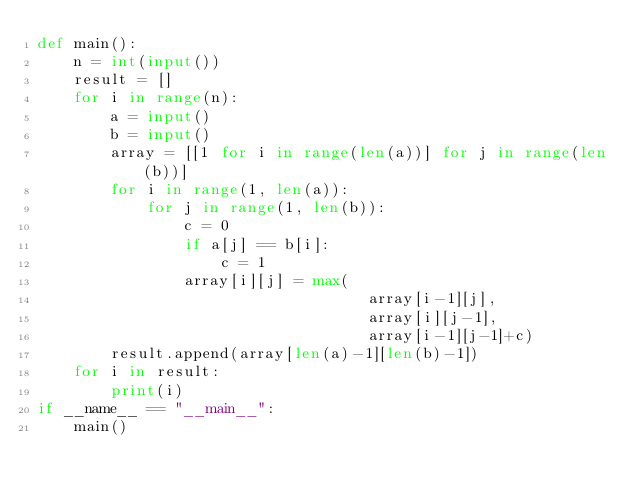<code> <loc_0><loc_0><loc_500><loc_500><_Python_>def main():
    n = int(input())
    result = []
    for i in range(n):
        a = input()
        b = input()
        array = [[1 for i in range(len(a))] for j in range(len(b))]
        for i in range(1, len(a)):
            for j in range(1, len(b)):
                c = 0
                if a[j] == b[i]:
                    c = 1
                array[i][j] = max(
                                    array[i-1][j],
                                    array[i][j-1],
                                    array[i-1][j-1]+c)
        result.append(array[len(a)-1][len(b)-1])
    for i in result:
        print(i)
if __name__ == "__main__":
    main()

</code> 